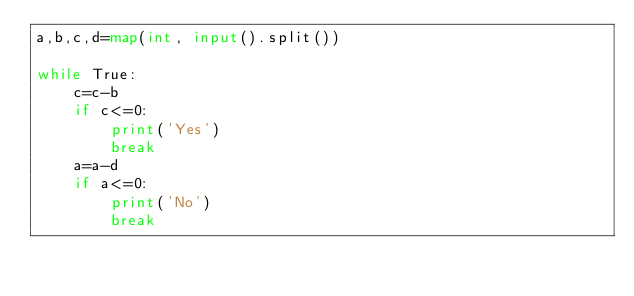Convert code to text. <code><loc_0><loc_0><loc_500><loc_500><_Python_>a,b,c,d=map(int, input().split())

while True:
    c=c-b
    if c<=0:
        print('Yes')
        break
    a=a-d
    if a<=0:
        print('No')
        break</code> 